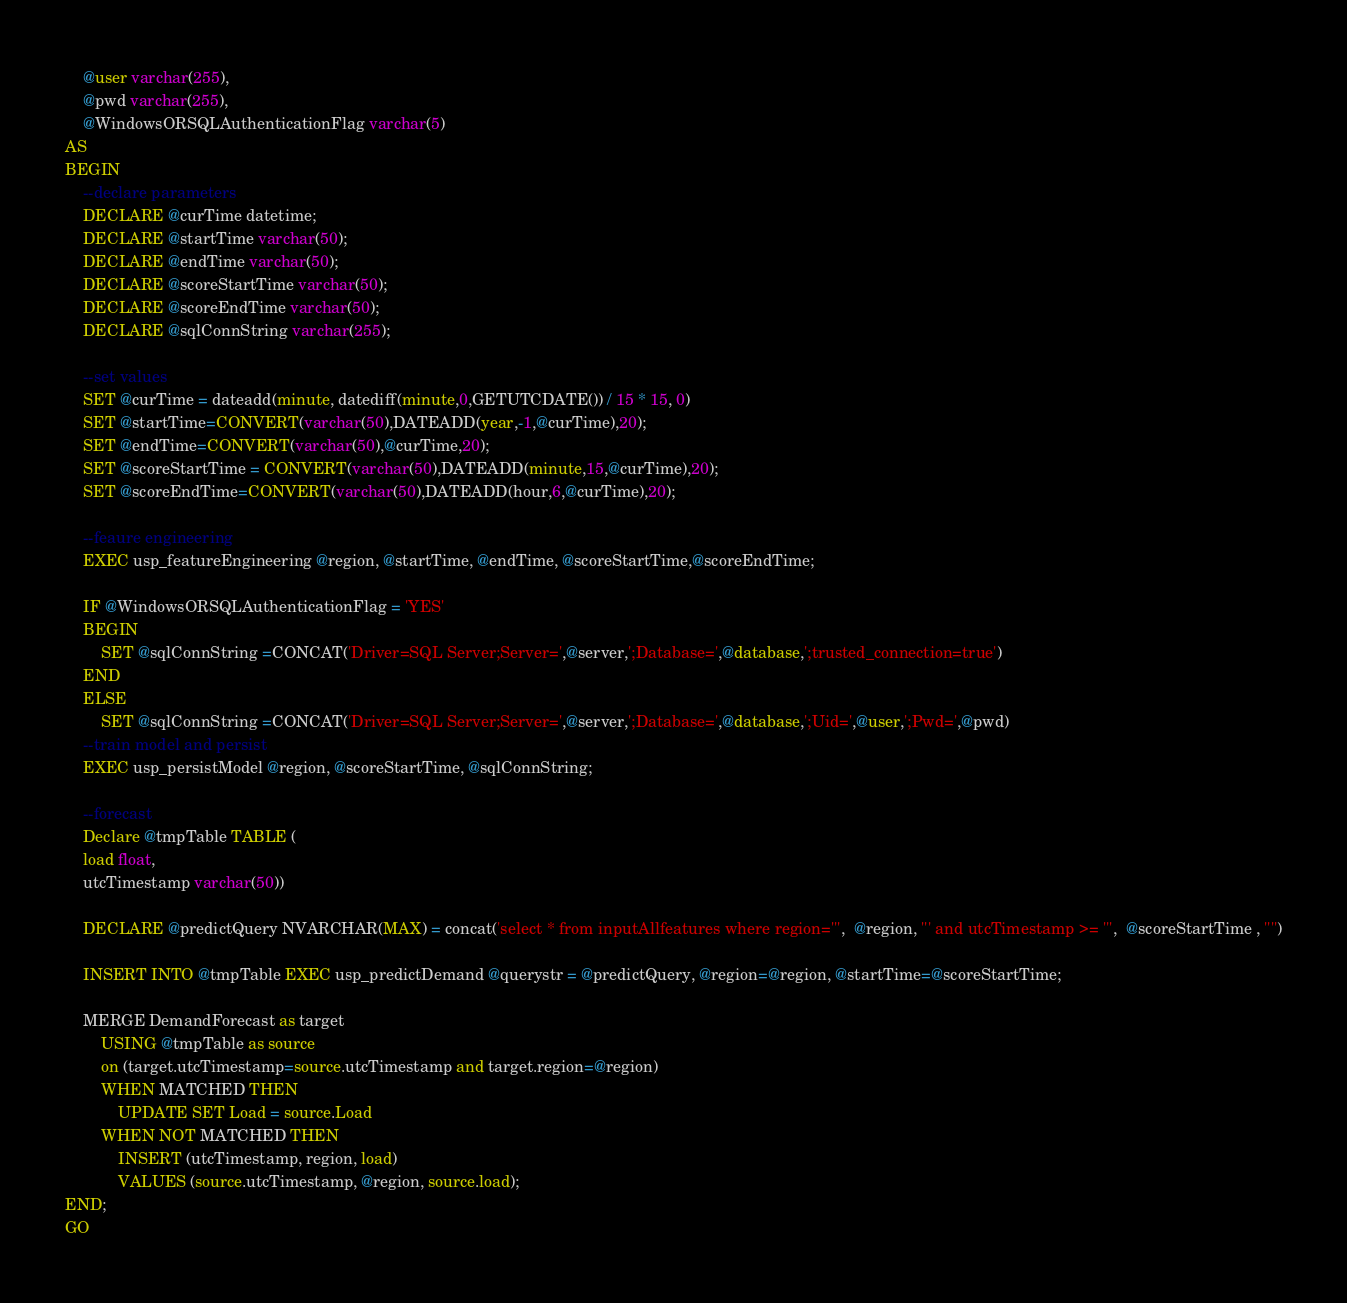Convert code to text. <code><loc_0><loc_0><loc_500><loc_500><_SQL_>	@user varchar(255),
	@pwd varchar(255),
	@WindowsORSQLAuthenticationFlag varchar(5)
AS
BEGIN
	--declare parameters
	DECLARE @curTime datetime;	
	DECLARE @startTime varchar(50);
	DECLARE @endTime varchar(50);
	DECLARE @scoreStartTime varchar(50);
	DECLARE @scoreEndTime varchar(50);
	DECLARE @sqlConnString varchar(255);

	--set values
	SET @curTime = dateadd(minute, datediff(minute,0,GETUTCDATE()) / 15 * 15, 0)	
	SET @startTime=CONVERT(varchar(50),DATEADD(year,-1,@curTime),20);
	SET @endTime=CONVERT(varchar(50),@curTime,20);
	SET @scoreStartTime = CONVERT(varchar(50),DATEADD(minute,15,@curTime),20);
	SET @scoreEndTime=CONVERT(varchar(50),DATEADD(hour,6,@curTime),20);

	--feaure engineering
	EXEC usp_featureEngineering @region, @startTime, @endTime, @scoreStartTime,@scoreEndTime;
	
	IF @WindowsORSQLAuthenticationFlag = 'YES'
	BEGIN
		SET @sqlConnString =CONCAT('Driver=SQL Server;Server=',@server,';Database=',@database,';trusted_connection=true')
	END
	ELSE
		SET @sqlConnString =CONCAT('Driver=SQL Server;Server=',@server,';Database=',@database,';Uid=',@user,';Pwd=',@pwd)
	--train model and persist
	EXEC usp_persistModel @region, @scoreStartTime, @sqlConnString; 

	--forecast
	Declare @tmpTable TABLE (
	load float,
	utcTimestamp varchar(50))

	DECLARE @predictQuery NVARCHAR(MAX) = concat('select * from inputAllfeatures where region=''',  @region, ''' and utcTimestamp >= ''',  @scoreStartTime , '''')

	INSERT INTO @tmpTable EXEC usp_predictDemand @querystr = @predictQuery, @region=@region, @startTime=@scoreStartTime;
					
	MERGE DemandForecast as target 
		USING @tmpTable as source
		on (target.utcTimestamp=source.utcTimestamp and target.region=@region)
		WHEN MATCHED THEN
			UPDATE SET Load = source.Load
		WHEN NOT MATCHED THEN
			INSERT (utcTimestamp, region, load)
			VALUES (source.utcTimestamp, @region, source.load);
END;
GO</code> 